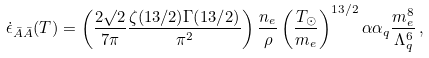<formula> <loc_0><loc_0><loc_500><loc_500>\dot { \epsilon } _ { \bar { A } \bar { A } } ( T ) = \left ( \frac { 2 \surd { 2 } } { 7 \pi } \frac { \zeta ( 1 3 / 2 ) \Gamma ( 1 3 / 2 ) } { \pi ^ { 2 } } \right ) \frac { n _ { e } } { \rho } \left ( \frac { T _ { \odot } } { m _ { e } } \right ) ^ { 1 3 / 2 } \alpha \alpha _ { q } \frac { m _ { e } ^ { 8 } } { \Lambda _ { q } ^ { 6 } } \, ,</formula> 